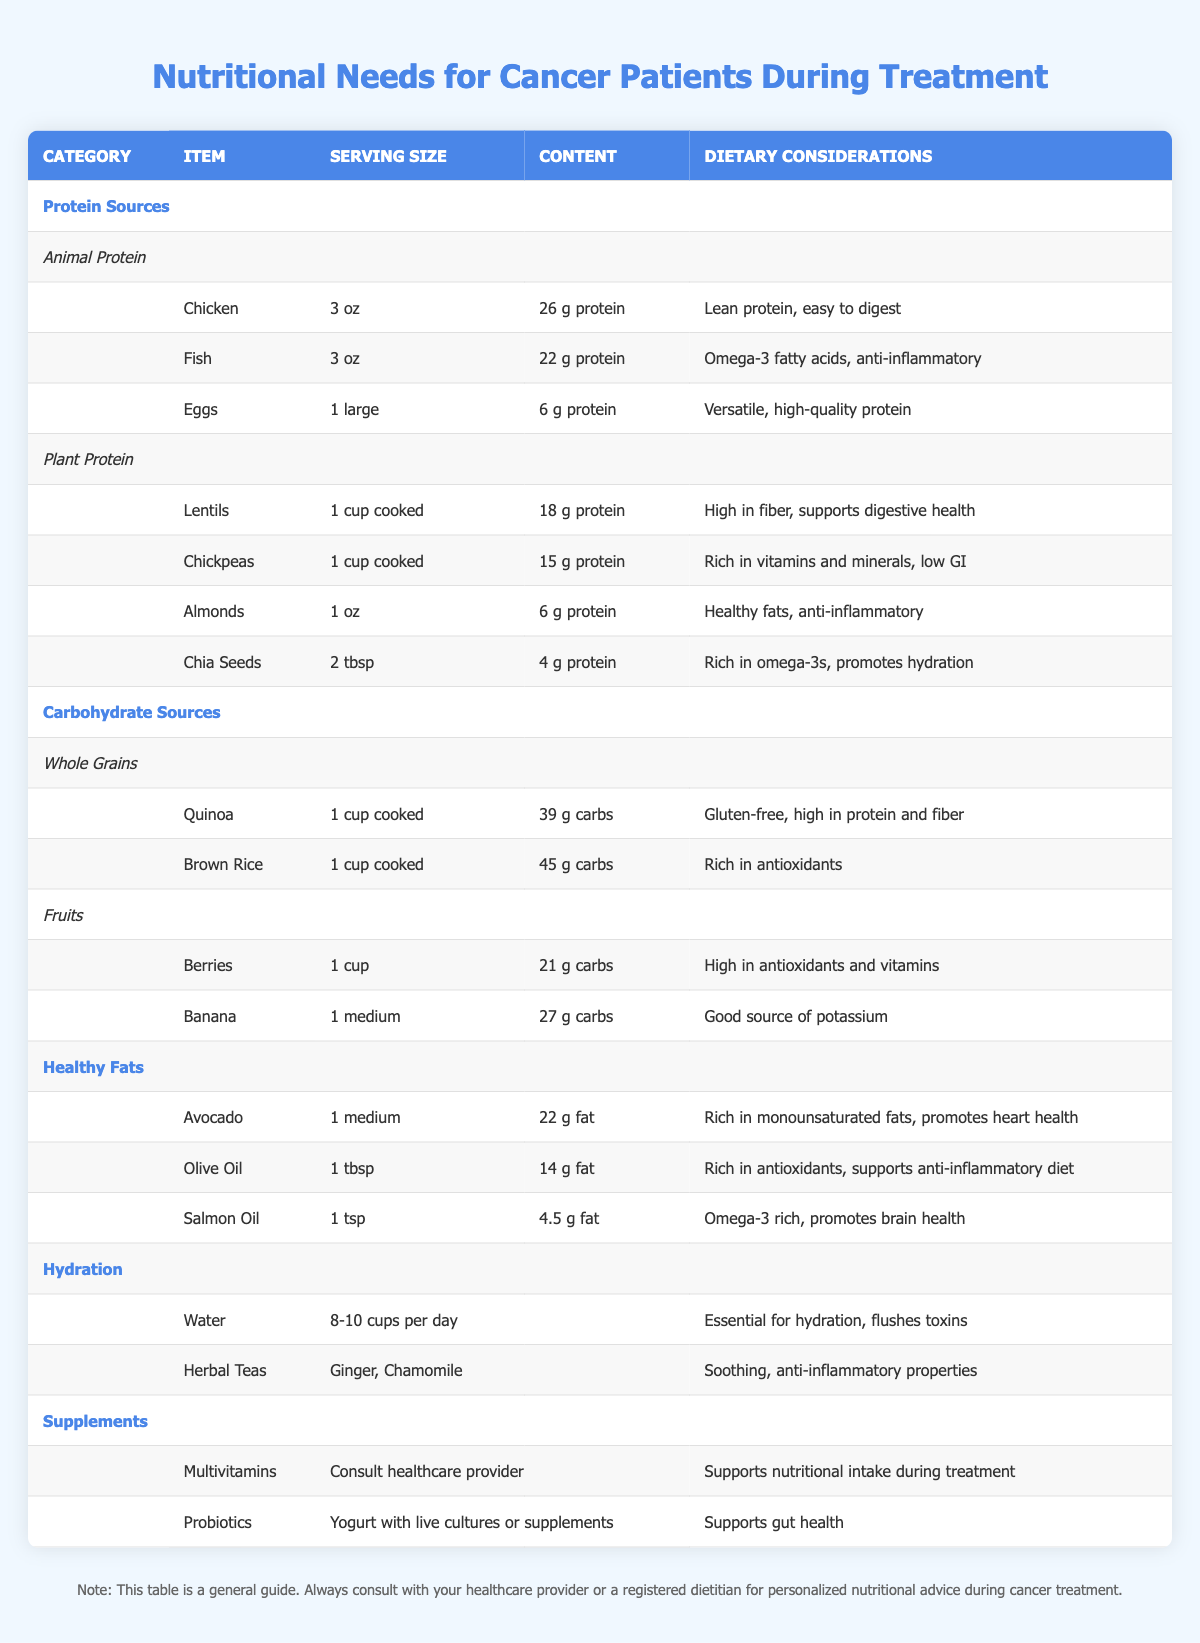What is the protein content in a serving of chicken? The table indicates that chicken has a protein content of 26 grams per serving of 3 ounces.
Answer: 26 g How much protein is in lentils compared to chickpeas? Lentils have 18 grams of protein per cup cooked, while chickpeas have 15 grams per cup cooked. To compare: 18 g (lentils) - 15 g (chickpeas) = 3 g difference.
Answer: 3 g Is quinoa gluten-free? The table states that quinoa is gluten-free, which is noted in the dietary considerations section for quinoa.
Answer: Yes Which source of healthy fat has the highest fat content per serving? The table lists avocado with 22 grams of fat per medium serving, olive oil with 14 grams per tablespoon, and salmon oil with 4.5 grams per teaspoon. Hence, avocado has the highest fat content.
Answer: Avocado What is the total carbohydrate content from one cup of cooked quinoa and one medium banana? Quinoa has 39 grams of carbohydrates per cup cooked, and banana has 27 grams. Combining these gives: 39 g + 27 g = 66 g total carbohydrate content.
Answer: 66 g How many cups of water are recommended per day? The table explicitly states that the recommendation is 8 to 10 cups of water per day.
Answer: 8-10 cups Are chickpeas a good source of vitamins and minerals? Yes, the table mentions that chickpeas are rich in vitamins and minerals, indicating their nutritional benefits.
Answer: Yes If I consume 1 cup of cooked brown rice, how many grams of carbohydrates would I have consumed? The table lists that 1 cup of cooked brown rice contains 45 grams of carbohydrates, thus confirming the content.
Answer: 45 g Which protein source has the lowest protein content per serving? According to the table, the item with the lowest protein content is chia seeds, at 4 grams of protein per 2 tablespoons.
Answer: Chia seeds 